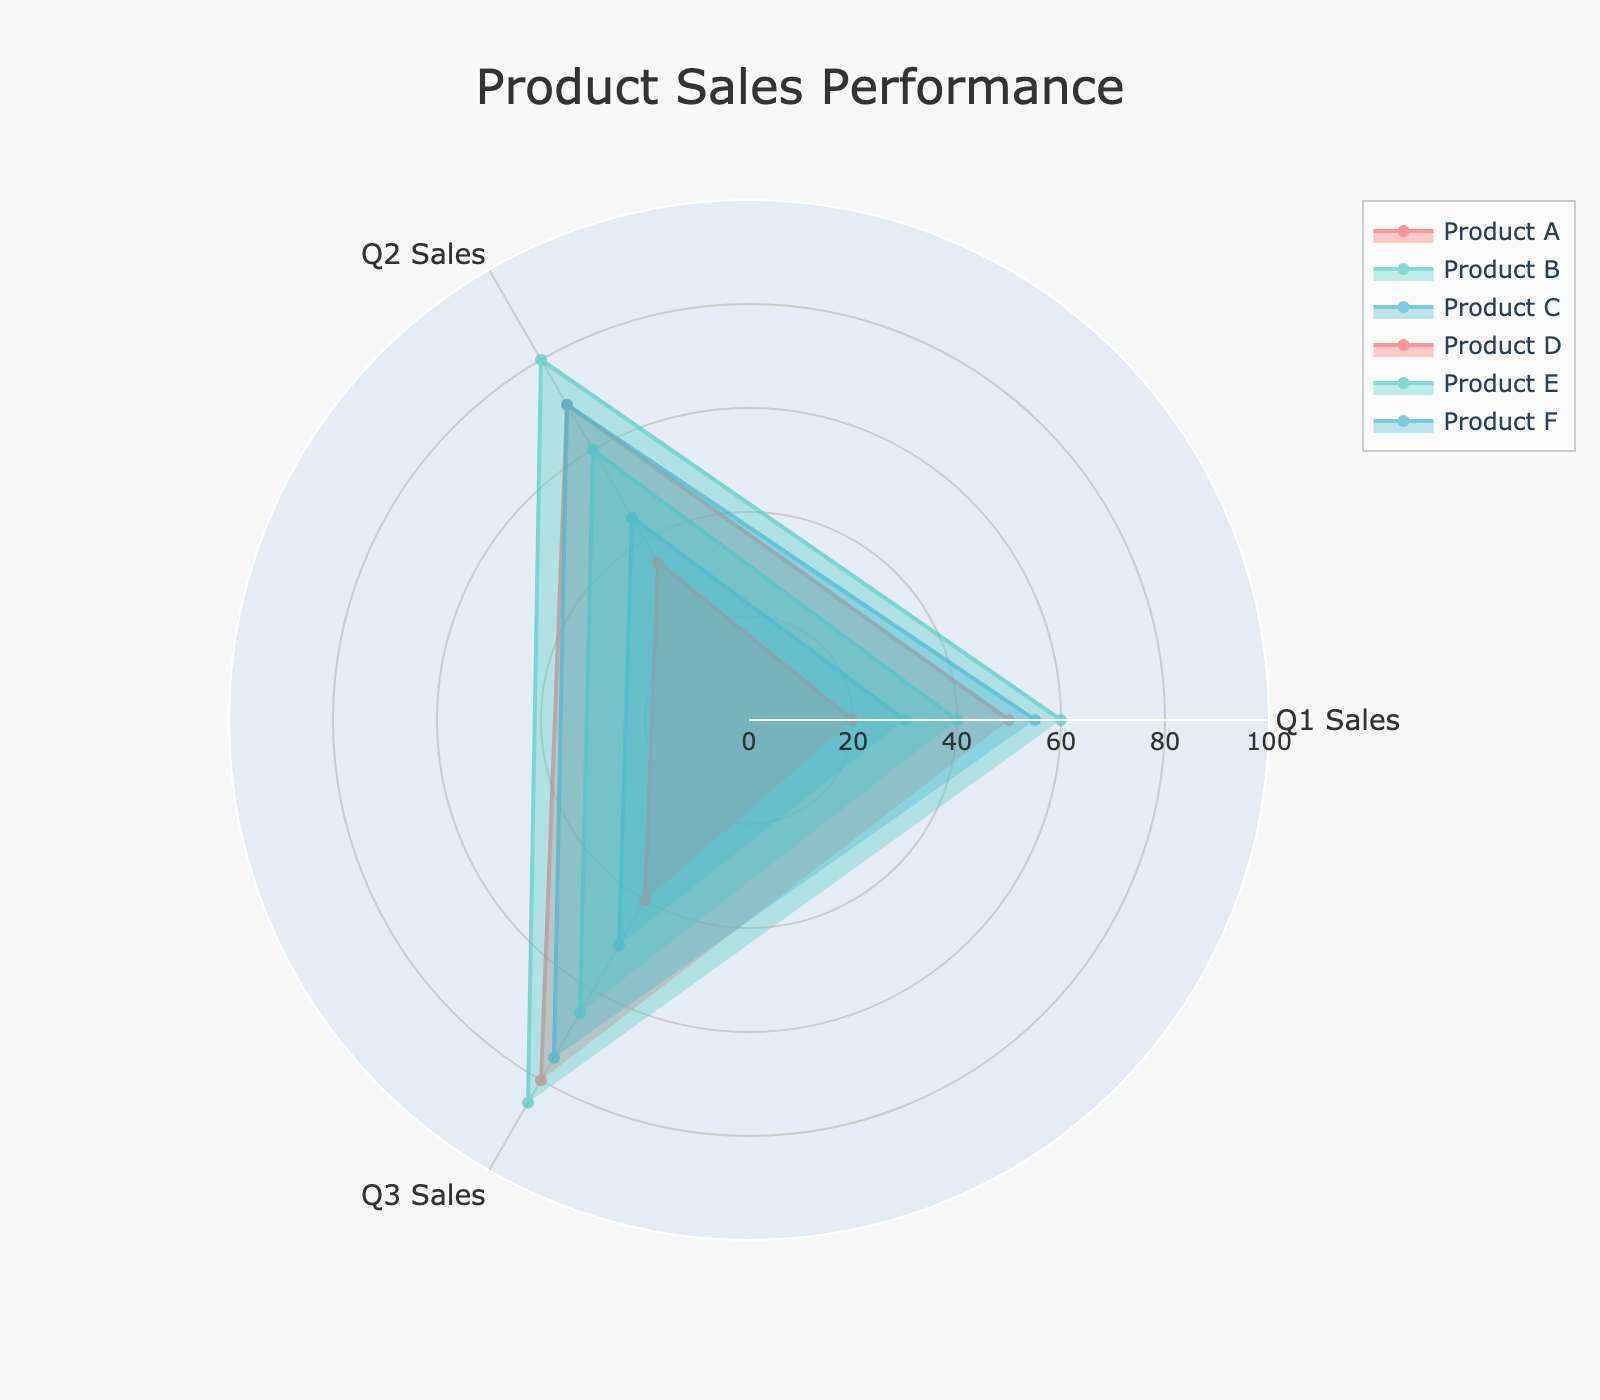Which product has the highest Q1 Sales? To determine this, observe the lengths of the radar chart segments for Q1 Sales. Product E has the longest segment for Q1 Sales, indicating it has the highest Q1 Sales.
Answer: Product E Which product shows the steepest increase in sales from Q1 to Q2? Compare the lengths of the radar chart segments between Q1 and Q2 for each product. Product A has the largest difference between the Q1 and Q2 segments, indicating a steep increase in sales.
Answer: Product A What is the average sales for Q2 across all products? Add the Q2 Sales for all products (70 + 60 + 45 + 35 + 80 + 70) and divide by the number of products (6). (70 + 60 + 45 + 35 + 80 + 70) / 6 = 360 / 6 = 60
Answer: 60 Which product had the lowest sales in Q3? Look for the shortest segment in the Q3 part of the radar chart. Product D has the shortest segment in Q3, indicating the lowest sales.
Answer: Product D How do Q1 Sales for Product C compare to Q2 Sales for Product B? Compare the lengths of the segments for Q1 Sales of Product C and Q2 Sales of Product B. Both segments are approximately the same length, indicating they have similar sales.
Answer: Approximately the same Which category had the highest average Q1 Sales? Determine the average Q1 Sales for each category. Electronics (Product A + Product B): (50 + 40) / 2 = 45, Furniture (Product C + Product D): (30 + 20) / 2 = 25, Apparel (Product E + Product F): (60 + 55) / 2 = 57.5. The Apparel category has the highest average Q1 Sales.
Answer: Apparel What is the total Q3 Sales for Electronics products? Sum the Q3 Sales for Product A and Product B (80 + 65). 80 + 65 = 145
Answer: 145 Which product showed consistent sales growth across all three quarters? Look for products where each subsequent segment in the radar chart is longer than the previous one. Product A and Product E show consistent sales growth.
Answer: Product A, Product E 